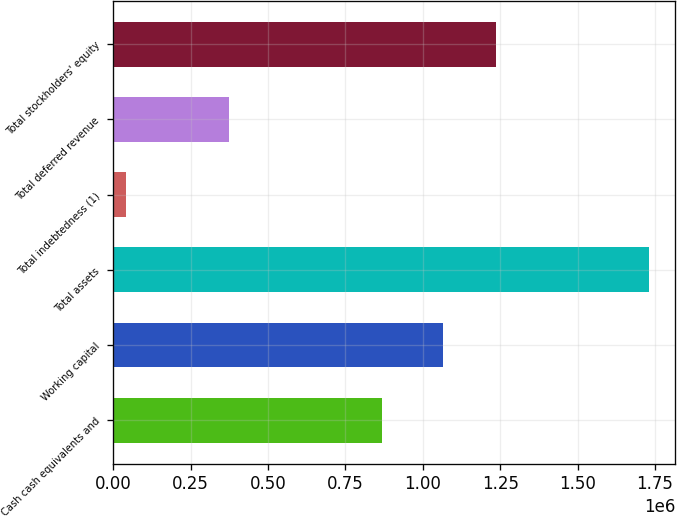Convert chart to OTSL. <chart><loc_0><loc_0><loc_500><loc_500><bar_chart><fcel>Cash cash equivalents and<fcel>Working capital<fcel>Total assets<fcel>Total indebtedness (1)<fcel>Total deferred revenue<fcel>Total stockholders' equity<nl><fcel>867833<fcel>1.06657e+06<fcel>1.72901e+06<fcel>41210<fcel>372935<fcel>1.23535e+06<nl></chart> 